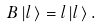Convert formula to latex. <formula><loc_0><loc_0><loc_500><loc_500>B \, | l \, \rangle = l \, | l \, \rangle \, .</formula> 